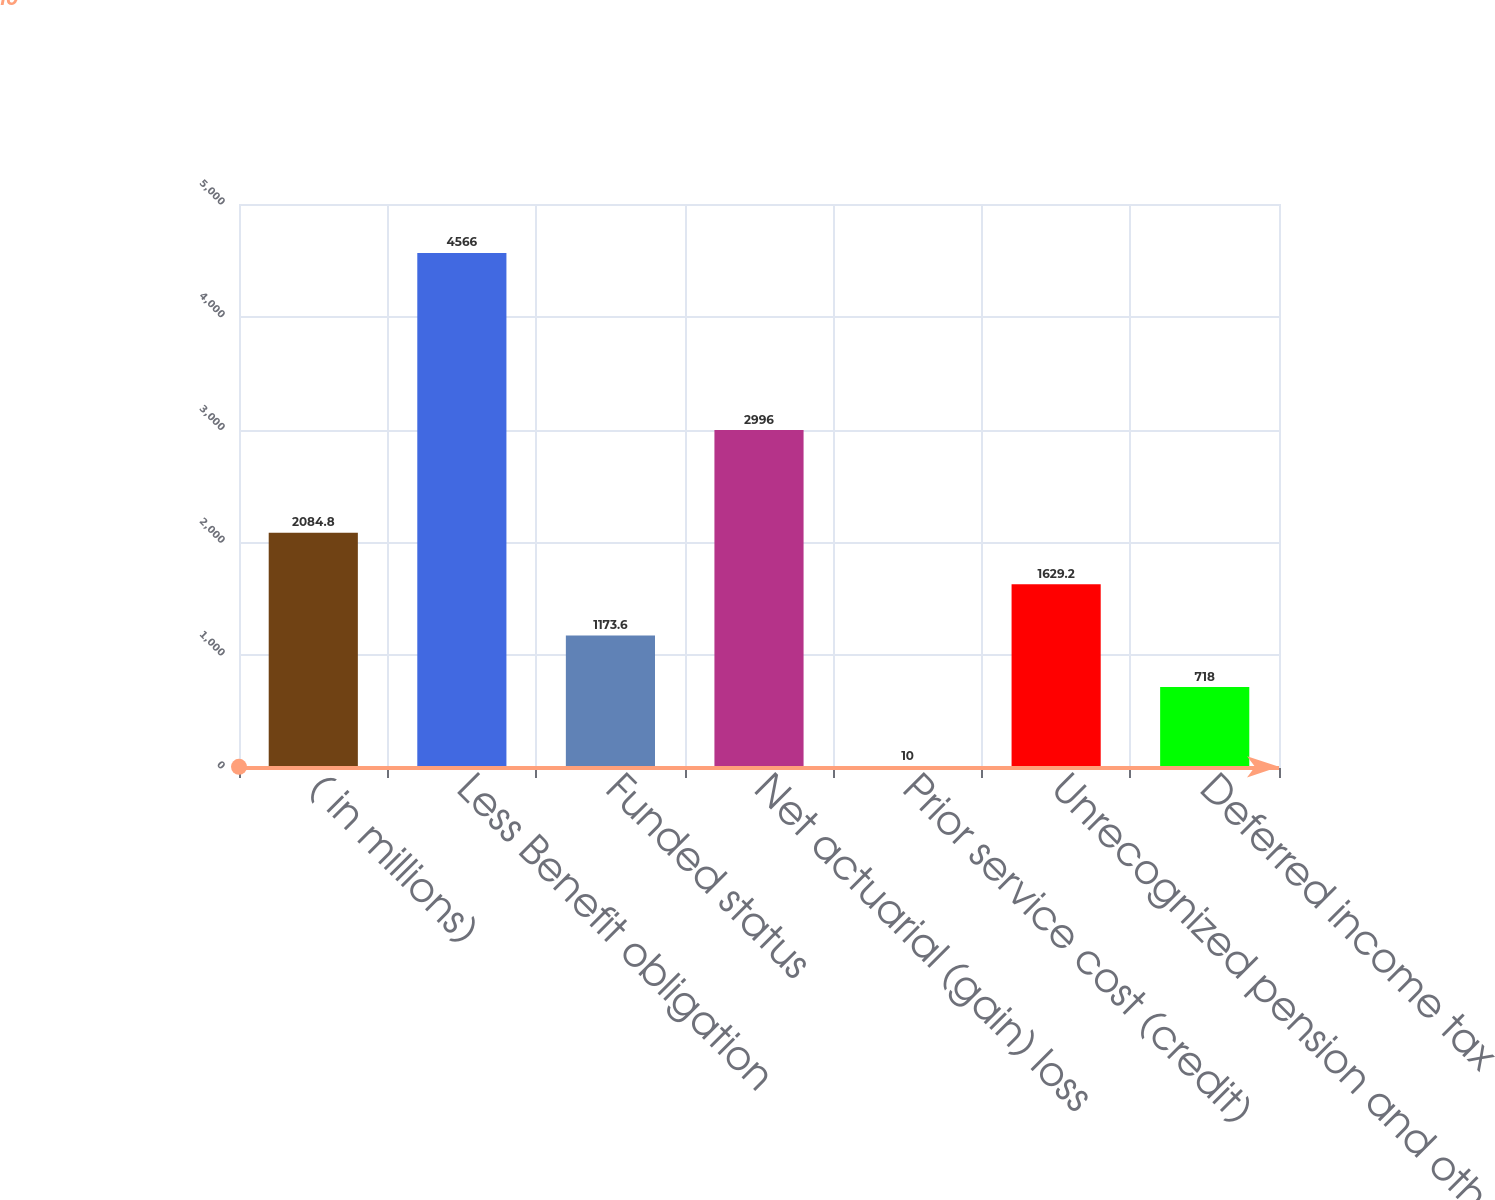<chart> <loc_0><loc_0><loc_500><loc_500><bar_chart><fcel>( in millions)<fcel>Less Benefit obligation<fcel>Funded status<fcel>Net actuarial (gain) loss<fcel>Prior service cost (credit)<fcel>Unrecognized pension and other<fcel>Deferred income tax<nl><fcel>2084.8<fcel>4566<fcel>1173.6<fcel>2996<fcel>10<fcel>1629.2<fcel>718<nl></chart> 